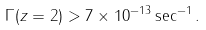<formula> <loc_0><loc_0><loc_500><loc_500>\Gamma ( z = 2 ) > 7 \times 1 0 ^ { - 1 3 } \sec ^ { - 1 } .</formula> 